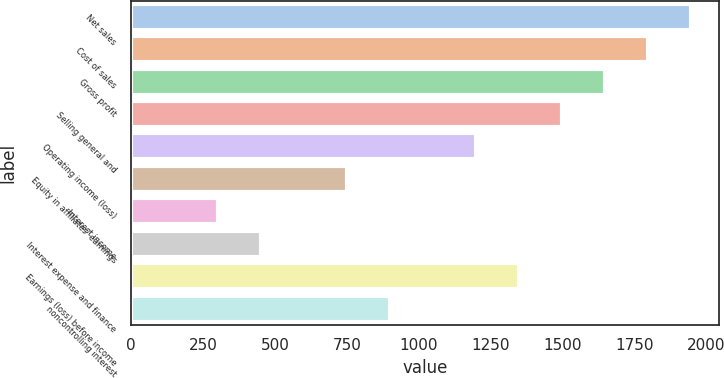Convert chart. <chart><loc_0><loc_0><loc_500><loc_500><bar_chart><fcel>Net sales<fcel>Cost of sales<fcel>Gross profit<fcel>Selling general and<fcel>Operating income (loss)<fcel>Equity in affiliates' earnings<fcel>Interest income<fcel>Interest expense and finance<fcel>Earnings (loss) before income<fcel>noncontrolling interest<nl><fcel>1948.37<fcel>1798.55<fcel>1648.73<fcel>1498.91<fcel>1199.28<fcel>749.83<fcel>300.38<fcel>450.2<fcel>1349.1<fcel>899.65<nl></chart> 